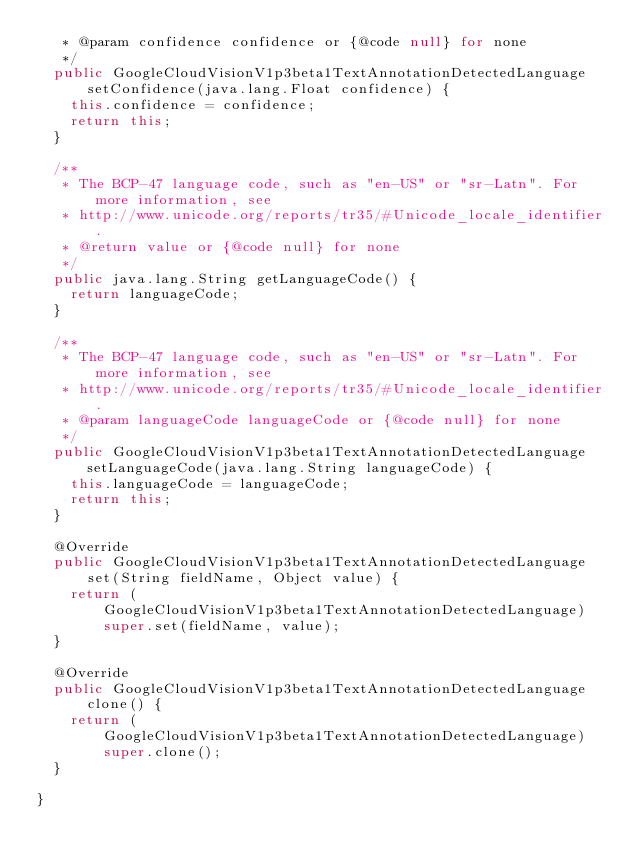Convert code to text. <code><loc_0><loc_0><loc_500><loc_500><_Java_>   * @param confidence confidence or {@code null} for none
   */
  public GoogleCloudVisionV1p3beta1TextAnnotationDetectedLanguage setConfidence(java.lang.Float confidence) {
    this.confidence = confidence;
    return this;
  }

  /**
   * The BCP-47 language code, such as "en-US" or "sr-Latn". For more information, see
   * http://www.unicode.org/reports/tr35/#Unicode_locale_identifier.
   * @return value or {@code null} for none
   */
  public java.lang.String getLanguageCode() {
    return languageCode;
  }

  /**
   * The BCP-47 language code, such as "en-US" or "sr-Latn". For more information, see
   * http://www.unicode.org/reports/tr35/#Unicode_locale_identifier.
   * @param languageCode languageCode or {@code null} for none
   */
  public GoogleCloudVisionV1p3beta1TextAnnotationDetectedLanguage setLanguageCode(java.lang.String languageCode) {
    this.languageCode = languageCode;
    return this;
  }

  @Override
  public GoogleCloudVisionV1p3beta1TextAnnotationDetectedLanguage set(String fieldName, Object value) {
    return (GoogleCloudVisionV1p3beta1TextAnnotationDetectedLanguage) super.set(fieldName, value);
  }

  @Override
  public GoogleCloudVisionV1p3beta1TextAnnotationDetectedLanguage clone() {
    return (GoogleCloudVisionV1p3beta1TextAnnotationDetectedLanguage) super.clone();
  }

}
</code> 